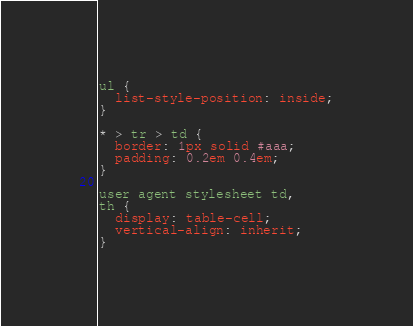<code> <loc_0><loc_0><loc_500><loc_500><_CSS_>ul {
  list-style-position: inside;
}

* > tr > td {
  border: 1px solid #aaa;
  padding: 0.2em 0.4em;
}

user agent stylesheet td,
th {
  display: table-cell;
  vertical-align: inherit;
}</code> 